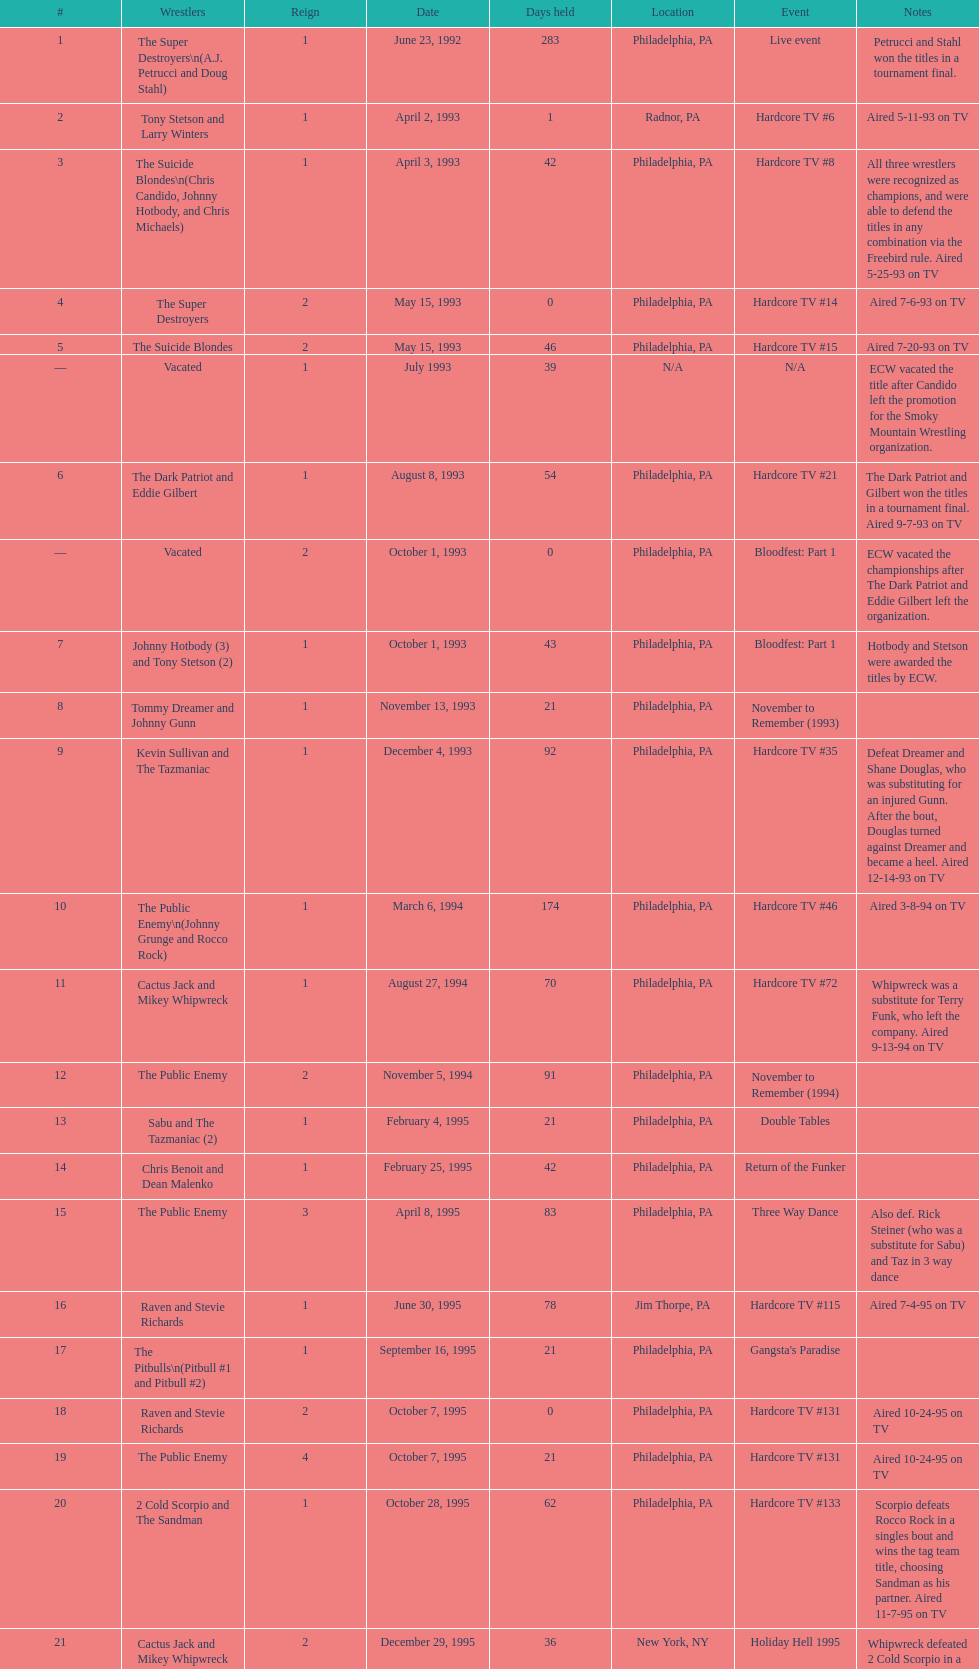How many times, from june 23, 1992 to december 3, 2000, did the suicide blondes hold the title? 2. 